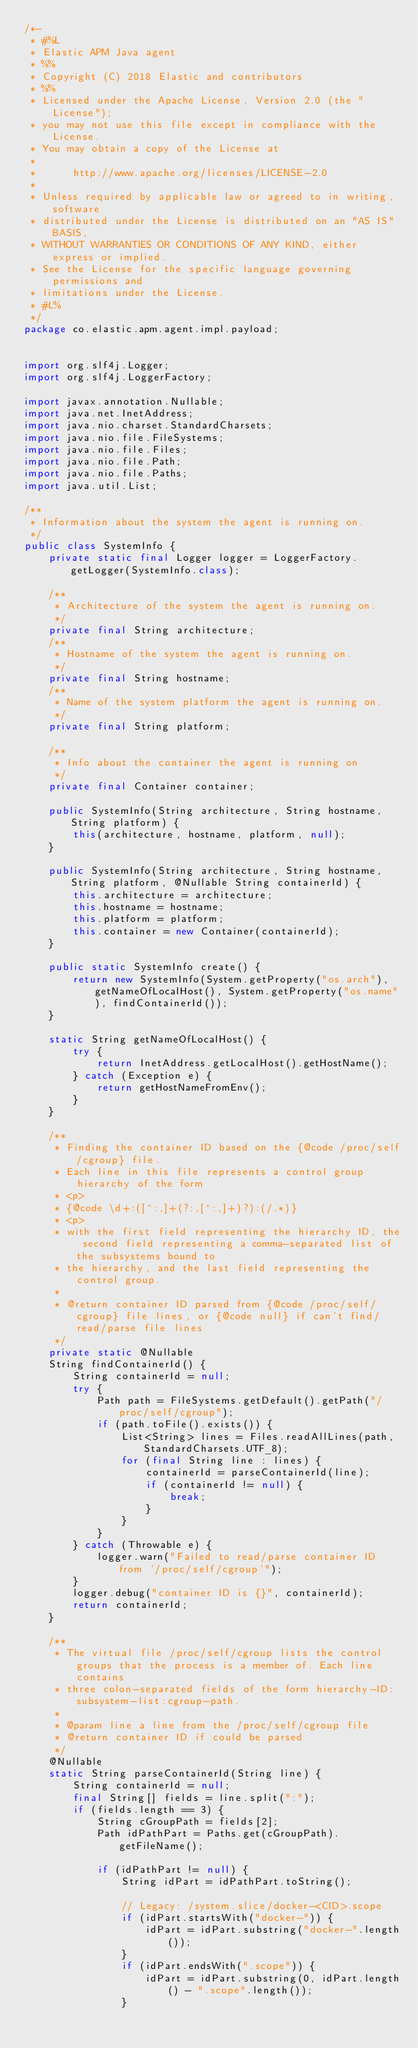Convert code to text. <code><loc_0><loc_0><loc_500><loc_500><_Java_>/*-
 * #%L
 * Elastic APM Java agent
 * %%
 * Copyright (C) 2018 Elastic and contributors
 * %%
 * Licensed under the Apache License, Version 2.0 (the "License");
 * you may not use this file except in compliance with the License.
 * You may obtain a copy of the License at
 *
 *      http://www.apache.org/licenses/LICENSE-2.0
 *
 * Unless required by applicable law or agreed to in writing, software
 * distributed under the License is distributed on an "AS IS" BASIS,
 * WITHOUT WARRANTIES OR CONDITIONS OF ANY KIND, either express or implied.
 * See the License for the specific language governing permissions and
 * limitations under the License.
 * #L%
 */
package co.elastic.apm.agent.impl.payload;


import org.slf4j.Logger;
import org.slf4j.LoggerFactory;

import javax.annotation.Nullable;
import java.net.InetAddress;
import java.nio.charset.StandardCharsets;
import java.nio.file.FileSystems;
import java.nio.file.Files;
import java.nio.file.Path;
import java.nio.file.Paths;
import java.util.List;

/**
 * Information about the system the agent is running on.
 */
public class SystemInfo {
    private static final Logger logger = LoggerFactory.getLogger(SystemInfo.class);

    /**
     * Architecture of the system the agent is running on.
     */
    private final String architecture;
    /**
     * Hostname of the system the agent is running on.
     */
    private final String hostname;
    /**
     * Name of the system platform the agent is running on.
     */
    private final String platform;

    /**
     * Info about the container the agent is running on
     */
    private final Container container;

    public SystemInfo(String architecture, String hostname, String platform) {
        this(architecture, hostname, platform, null);
    }

    public SystemInfo(String architecture, String hostname, String platform, @Nullable String containerId) {
        this.architecture = architecture;
        this.hostname = hostname;
        this.platform = platform;
        this.container = new Container(containerId);
    }

    public static SystemInfo create() {
        return new SystemInfo(System.getProperty("os.arch"), getNameOfLocalHost(), System.getProperty("os.name"), findContainerId());
    }

    static String getNameOfLocalHost() {
        try {
            return InetAddress.getLocalHost().getHostName();
        } catch (Exception e) {
            return getHostNameFromEnv();
        }
    }

    /**
     * Finding the container ID based on the {@code /proc/self/cgroup} file.
     * Each line in this file represents a control group hierarchy of the form
     * <p>
     * {@code \d+:([^:,]+(?:,[^:,]+)?):(/.*)}
     * <p>
     * with the first field representing the hierarchy ID, the second field representing a comma-separated list of the subsystems bound to
     * the hierarchy, and the last field representing the control group.
     *
     * @return container ID parsed from {@code /proc/self/cgroup} file lines, or {@code null} if can't find/read/parse file lines
     */
    private static @Nullable
    String findContainerId() {
        String containerId = null;
        try {
            Path path = FileSystems.getDefault().getPath("/proc/self/cgroup");
            if (path.toFile().exists()) {
                List<String> lines = Files.readAllLines(path, StandardCharsets.UTF_8);
                for (final String line : lines) {
                    containerId = parseContainerId(line);
                    if (containerId != null) {
                        break;
                    }
                }
            }
        } catch (Throwable e) {
            logger.warn("Failed to read/parse container ID from '/proc/self/cgroup'");
        }
        logger.debug("container ID is {}", containerId);
        return containerId;
    }

    /**
     * The virtual file /proc/self/cgroup lists the control groups that the process is a member of. Each line contains
     * three colon-separated fields of the form hierarchy-ID:subsystem-list:cgroup-path.
     *
     * @param line a line from the /proc/self/cgroup file
     * @return container ID if could be parsed
     */
    @Nullable
    static String parseContainerId(String line) {
        String containerId = null;
        final String[] fields = line.split(":");
        if (fields.length == 3) {
            String cGroupPath = fields[2];
            Path idPathPart = Paths.get(cGroupPath).getFileName();

            if (idPathPart != null) {
                String idPart = idPathPart.toString();

                // Legacy: /system.slice/docker-<CID>.scope
                if (idPart.startsWith("docker-")) {
                    idPart = idPart.substring("docker-".length());
                }
                if (idPart.endsWith(".scope")) {
                    idPart = idPart.substring(0, idPart.length() - ".scope".length());
                }
</code> 